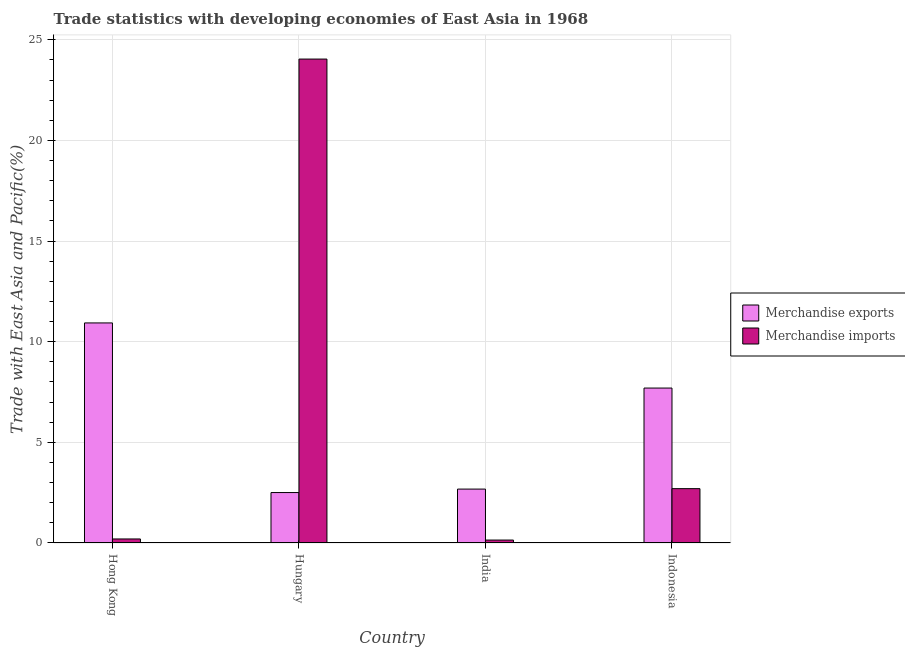Are the number of bars per tick equal to the number of legend labels?
Ensure brevity in your answer.  Yes. What is the label of the 1st group of bars from the left?
Keep it short and to the point. Hong Kong. What is the merchandise imports in India?
Ensure brevity in your answer.  0.15. Across all countries, what is the maximum merchandise exports?
Offer a very short reply. 10.93. Across all countries, what is the minimum merchandise imports?
Give a very brief answer. 0.15. In which country was the merchandise imports maximum?
Ensure brevity in your answer.  Hungary. In which country was the merchandise exports minimum?
Offer a very short reply. Hungary. What is the total merchandise exports in the graph?
Your response must be concise. 23.81. What is the difference between the merchandise imports in Hungary and that in Indonesia?
Keep it short and to the point. 21.34. What is the difference between the merchandise imports in Hungary and the merchandise exports in Hong Kong?
Offer a terse response. 13.11. What is the average merchandise exports per country?
Your response must be concise. 5.95. What is the difference between the merchandise exports and merchandise imports in Indonesia?
Ensure brevity in your answer.  5. What is the ratio of the merchandise exports in Hong Kong to that in India?
Provide a succinct answer. 4.08. Is the difference between the merchandise imports in Hong Kong and India greater than the difference between the merchandise exports in Hong Kong and India?
Your response must be concise. No. What is the difference between the highest and the second highest merchandise imports?
Ensure brevity in your answer.  21.34. What is the difference between the highest and the lowest merchandise exports?
Offer a terse response. 8.43. What does the 1st bar from the right in Indonesia represents?
Provide a succinct answer. Merchandise imports. Where does the legend appear in the graph?
Ensure brevity in your answer.  Center right. What is the title of the graph?
Provide a succinct answer. Trade statistics with developing economies of East Asia in 1968. Does "Exports of goods" appear as one of the legend labels in the graph?
Your response must be concise. No. What is the label or title of the Y-axis?
Your answer should be very brief. Trade with East Asia and Pacific(%). What is the Trade with East Asia and Pacific(%) in Merchandise exports in Hong Kong?
Your answer should be compact. 10.93. What is the Trade with East Asia and Pacific(%) in Merchandise imports in Hong Kong?
Give a very brief answer. 0.2. What is the Trade with East Asia and Pacific(%) in Merchandise exports in Hungary?
Provide a succinct answer. 2.51. What is the Trade with East Asia and Pacific(%) of Merchandise imports in Hungary?
Your answer should be compact. 24.04. What is the Trade with East Asia and Pacific(%) of Merchandise exports in India?
Your answer should be very brief. 2.68. What is the Trade with East Asia and Pacific(%) of Merchandise imports in India?
Provide a short and direct response. 0.15. What is the Trade with East Asia and Pacific(%) of Merchandise exports in Indonesia?
Provide a short and direct response. 7.7. What is the Trade with East Asia and Pacific(%) of Merchandise imports in Indonesia?
Your answer should be compact. 2.7. Across all countries, what is the maximum Trade with East Asia and Pacific(%) of Merchandise exports?
Offer a terse response. 10.93. Across all countries, what is the maximum Trade with East Asia and Pacific(%) in Merchandise imports?
Offer a terse response. 24.04. Across all countries, what is the minimum Trade with East Asia and Pacific(%) of Merchandise exports?
Your answer should be very brief. 2.51. Across all countries, what is the minimum Trade with East Asia and Pacific(%) in Merchandise imports?
Make the answer very short. 0.15. What is the total Trade with East Asia and Pacific(%) of Merchandise exports in the graph?
Provide a short and direct response. 23.81. What is the total Trade with East Asia and Pacific(%) in Merchandise imports in the graph?
Your answer should be very brief. 27.09. What is the difference between the Trade with East Asia and Pacific(%) of Merchandise exports in Hong Kong and that in Hungary?
Make the answer very short. 8.43. What is the difference between the Trade with East Asia and Pacific(%) of Merchandise imports in Hong Kong and that in Hungary?
Provide a succinct answer. -23.84. What is the difference between the Trade with East Asia and Pacific(%) in Merchandise exports in Hong Kong and that in India?
Keep it short and to the point. 8.25. What is the difference between the Trade with East Asia and Pacific(%) of Merchandise imports in Hong Kong and that in India?
Offer a very short reply. 0.05. What is the difference between the Trade with East Asia and Pacific(%) of Merchandise exports in Hong Kong and that in Indonesia?
Keep it short and to the point. 3.24. What is the difference between the Trade with East Asia and Pacific(%) of Merchandise imports in Hong Kong and that in Indonesia?
Give a very brief answer. -2.5. What is the difference between the Trade with East Asia and Pacific(%) of Merchandise exports in Hungary and that in India?
Give a very brief answer. -0.17. What is the difference between the Trade with East Asia and Pacific(%) of Merchandise imports in Hungary and that in India?
Your response must be concise. 23.9. What is the difference between the Trade with East Asia and Pacific(%) in Merchandise exports in Hungary and that in Indonesia?
Keep it short and to the point. -5.19. What is the difference between the Trade with East Asia and Pacific(%) in Merchandise imports in Hungary and that in Indonesia?
Provide a short and direct response. 21.34. What is the difference between the Trade with East Asia and Pacific(%) in Merchandise exports in India and that in Indonesia?
Make the answer very short. -5.02. What is the difference between the Trade with East Asia and Pacific(%) in Merchandise imports in India and that in Indonesia?
Make the answer very short. -2.55. What is the difference between the Trade with East Asia and Pacific(%) in Merchandise exports in Hong Kong and the Trade with East Asia and Pacific(%) in Merchandise imports in Hungary?
Your answer should be compact. -13.11. What is the difference between the Trade with East Asia and Pacific(%) in Merchandise exports in Hong Kong and the Trade with East Asia and Pacific(%) in Merchandise imports in India?
Ensure brevity in your answer.  10.79. What is the difference between the Trade with East Asia and Pacific(%) of Merchandise exports in Hong Kong and the Trade with East Asia and Pacific(%) of Merchandise imports in Indonesia?
Make the answer very short. 8.23. What is the difference between the Trade with East Asia and Pacific(%) in Merchandise exports in Hungary and the Trade with East Asia and Pacific(%) in Merchandise imports in India?
Make the answer very short. 2.36. What is the difference between the Trade with East Asia and Pacific(%) of Merchandise exports in Hungary and the Trade with East Asia and Pacific(%) of Merchandise imports in Indonesia?
Provide a short and direct response. -0.19. What is the difference between the Trade with East Asia and Pacific(%) of Merchandise exports in India and the Trade with East Asia and Pacific(%) of Merchandise imports in Indonesia?
Ensure brevity in your answer.  -0.02. What is the average Trade with East Asia and Pacific(%) of Merchandise exports per country?
Keep it short and to the point. 5.95. What is the average Trade with East Asia and Pacific(%) in Merchandise imports per country?
Keep it short and to the point. 6.77. What is the difference between the Trade with East Asia and Pacific(%) in Merchandise exports and Trade with East Asia and Pacific(%) in Merchandise imports in Hong Kong?
Give a very brief answer. 10.73. What is the difference between the Trade with East Asia and Pacific(%) of Merchandise exports and Trade with East Asia and Pacific(%) of Merchandise imports in Hungary?
Keep it short and to the point. -21.54. What is the difference between the Trade with East Asia and Pacific(%) of Merchandise exports and Trade with East Asia and Pacific(%) of Merchandise imports in India?
Give a very brief answer. 2.53. What is the difference between the Trade with East Asia and Pacific(%) of Merchandise exports and Trade with East Asia and Pacific(%) of Merchandise imports in Indonesia?
Offer a very short reply. 5. What is the ratio of the Trade with East Asia and Pacific(%) of Merchandise exports in Hong Kong to that in Hungary?
Give a very brief answer. 4.36. What is the ratio of the Trade with East Asia and Pacific(%) in Merchandise imports in Hong Kong to that in Hungary?
Ensure brevity in your answer.  0.01. What is the ratio of the Trade with East Asia and Pacific(%) of Merchandise exports in Hong Kong to that in India?
Your answer should be compact. 4.08. What is the ratio of the Trade with East Asia and Pacific(%) in Merchandise imports in Hong Kong to that in India?
Your answer should be very brief. 1.37. What is the ratio of the Trade with East Asia and Pacific(%) of Merchandise exports in Hong Kong to that in Indonesia?
Ensure brevity in your answer.  1.42. What is the ratio of the Trade with East Asia and Pacific(%) in Merchandise imports in Hong Kong to that in Indonesia?
Offer a very short reply. 0.07. What is the ratio of the Trade with East Asia and Pacific(%) of Merchandise exports in Hungary to that in India?
Give a very brief answer. 0.94. What is the ratio of the Trade with East Asia and Pacific(%) of Merchandise imports in Hungary to that in India?
Offer a very short reply. 164.92. What is the ratio of the Trade with East Asia and Pacific(%) in Merchandise exports in Hungary to that in Indonesia?
Your answer should be compact. 0.33. What is the ratio of the Trade with East Asia and Pacific(%) of Merchandise imports in Hungary to that in Indonesia?
Your answer should be compact. 8.9. What is the ratio of the Trade with East Asia and Pacific(%) of Merchandise exports in India to that in Indonesia?
Your response must be concise. 0.35. What is the ratio of the Trade with East Asia and Pacific(%) in Merchandise imports in India to that in Indonesia?
Your answer should be compact. 0.05. What is the difference between the highest and the second highest Trade with East Asia and Pacific(%) in Merchandise exports?
Your answer should be compact. 3.24. What is the difference between the highest and the second highest Trade with East Asia and Pacific(%) in Merchandise imports?
Your response must be concise. 21.34. What is the difference between the highest and the lowest Trade with East Asia and Pacific(%) of Merchandise exports?
Your answer should be very brief. 8.43. What is the difference between the highest and the lowest Trade with East Asia and Pacific(%) in Merchandise imports?
Keep it short and to the point. 23.9. 